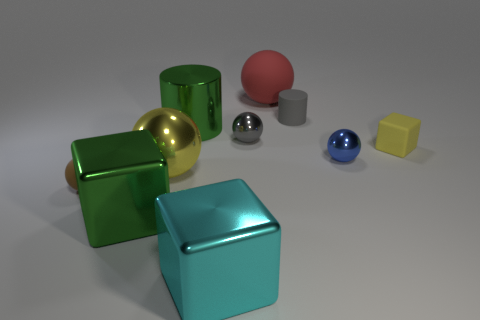How does the lighting in the image affect the appearance of the objects? The lighting in the image casts soft shadows and highlights, giving depth and dimension to the objects. It also enhances their reflective qualities, showcasing the glossiness of their surfaces. 